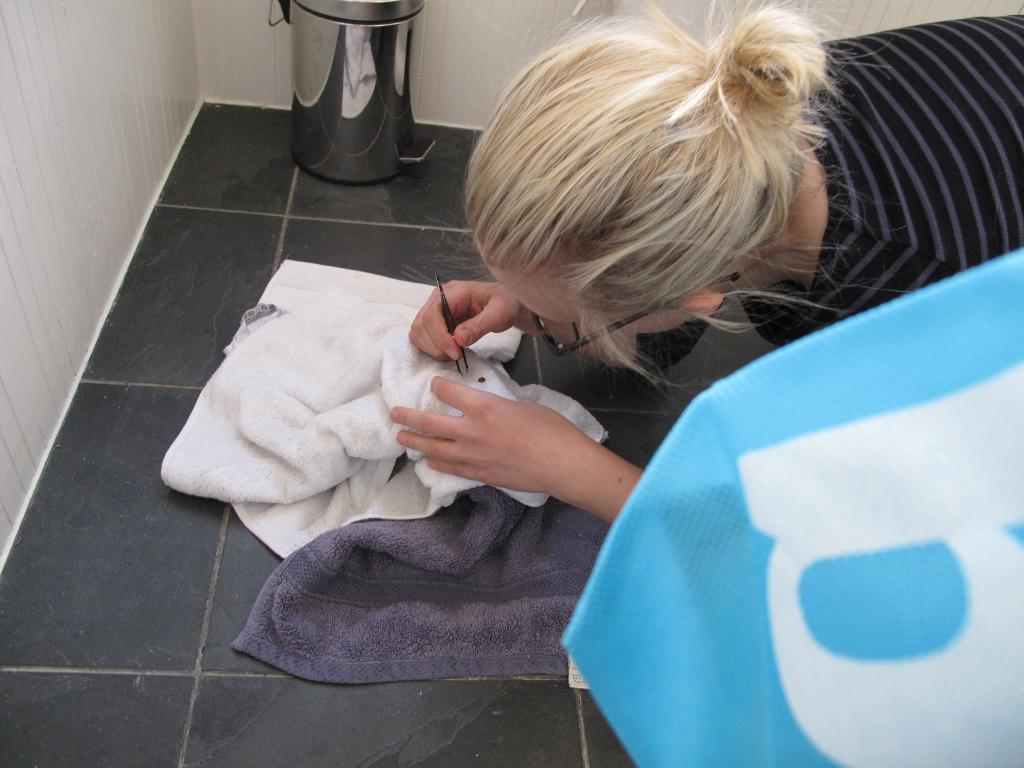<image>
Create a compact narrative representing the image presented. A woman laying on a floor uses tweezers to pick something up, a towel with the letter b on it to her left. 